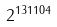<formula> <loc_0><loc_0><loc_500><loc_500>2 ^ { 1 3 1 1 0 4 }</formula> 